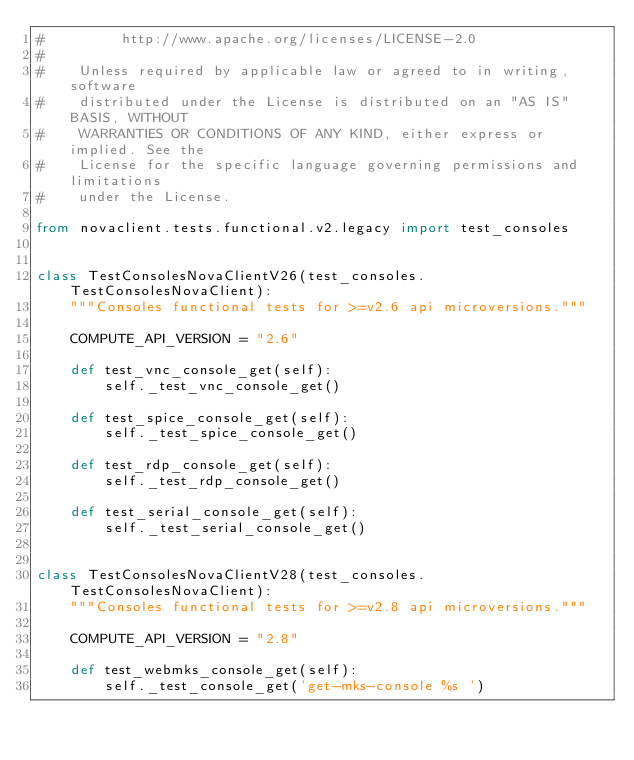Convert code to text. <code><loc_0><loc_0><loc_500><loc_500><_Python_>#         http://www.apache.org/licenses/LICENSE-2.0
#
#    Unless required by applicable law or agreed to in writing, software
#    distributed under the License is distributed on an "AS IS" BASIS, WITHOUT
#    WARRANTIES OR CONDITIONS OF ANY KIND, either express or implied. See the
#    License for the specific language governing permissions and limitations
#    under the License.

from novaclient.tests.functional.v2.legacy import test_consoles


class TestConsolesNovaClientV26(test_consoles.TestConsolesNovaClient):
    """Consoles functional tests for >=v2.6 api microversions."""

    COMPUTE_API_VERSION = "2.6"

    def test_vnc_console_get(self):
        self._test_vnc_console_get()

    def test_spice_console_get(self):
        self._test_spice_console_get()

    def test_rdp_console_get(self):
        self._test_rdp_console_get()

    def test_serial_console_get(self):
        self._test_serial_console_get()


class TestConsolesNovaClientV28(test_consoles.TestConsolesNovaClient):
    """Consoles functional tests for >=v2.8 api microversions."""

    COMPUTE_API_VERSION = "2.8"

    def test_webmks_console_get(self):
        self._test_console_get('get-mks-console %s ')
</code> 